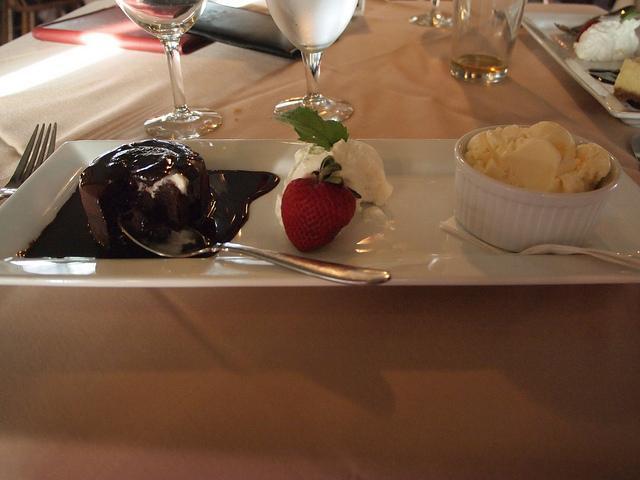What color is the chocolate on top of the white plate?
Make your selection from the four choices given to correctly answer the question.
Options: Brown, white, yellow, black. Black. 